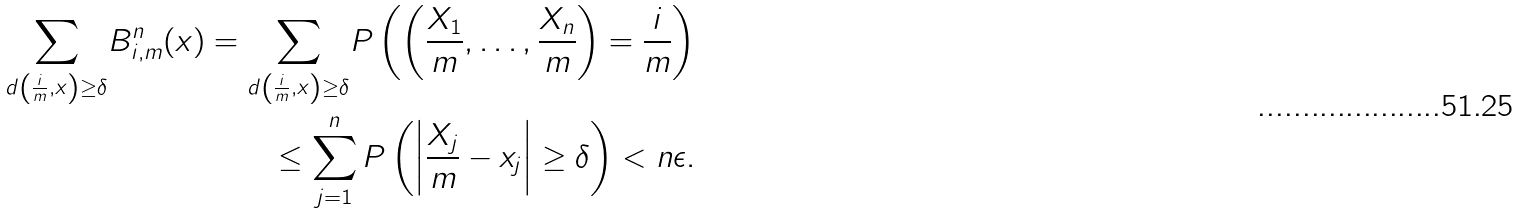Convert formula to latex. <formula><loc_0><loc_0><loc_500><loc_500>\underset { d \left ( \frac { i } { m } , x \right ) \geq \delta } { \sum } B ^ { n } _ { i , m } ( x ) = \underset { d \left ( \frac { i } { m } , x \right ) \geq \delta } { \sum } P \left ( \left ( \frac { X _ { 1 } } { m } , \dots , \frac { X _ { n } } { m } \right ) = \frac { i } { m } \right ) \\ \leq \sum _ { j = 1 } ^ { n } P \left ( \left | \frac { X _ { j } } { m } - x _ { j } \right | \geq \delta \right ) < n \epsilon .</formula> 